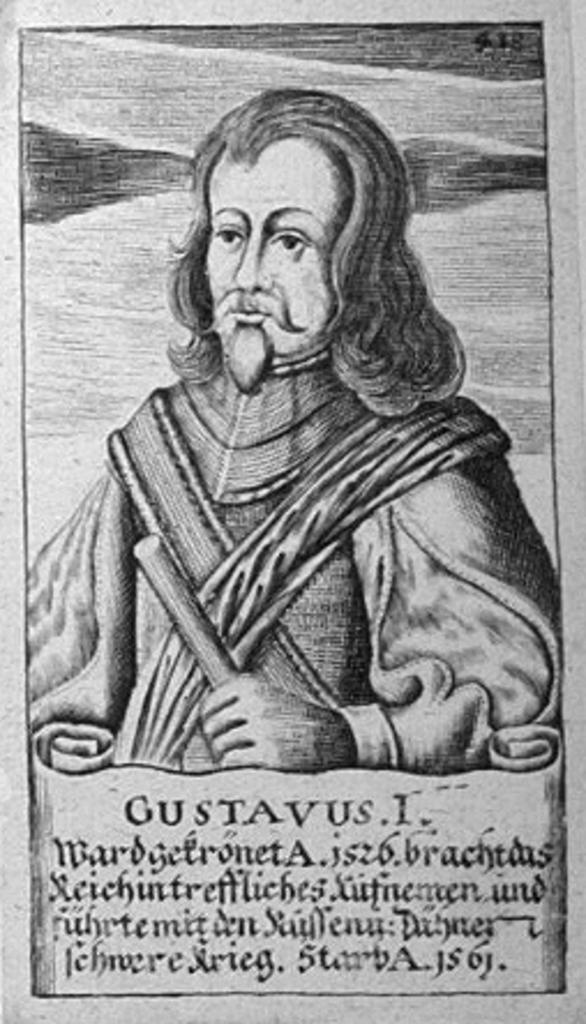What is featured in the image? There is a poster in the image. What is happening in the poster? The poster depicts a person holding an object in their hand. Is there any text on the poster? Yes, there is text written at the bottom of the poster. How many cakes are being served by the insect on the poster? There is no insect present on the poster, and therefore no cakes are being served by an insect. 